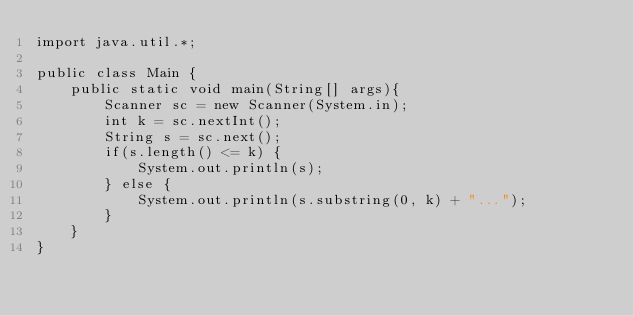Convert code to text. <code><loc_0><loc_0><loc_500><loc_500><_Java_>import java.util.*;

public class Main {
    public static void main(String[] args){
        Scanner sc = new Scanner(System.in);
        int k = sc.nextInt();
        String s = sc.next();
        if(s.length() <= k) {
            System.out.println(s);
        } else {
            System.out.println(s.substring(0, k) + "...");
        }
    }
}</code> 